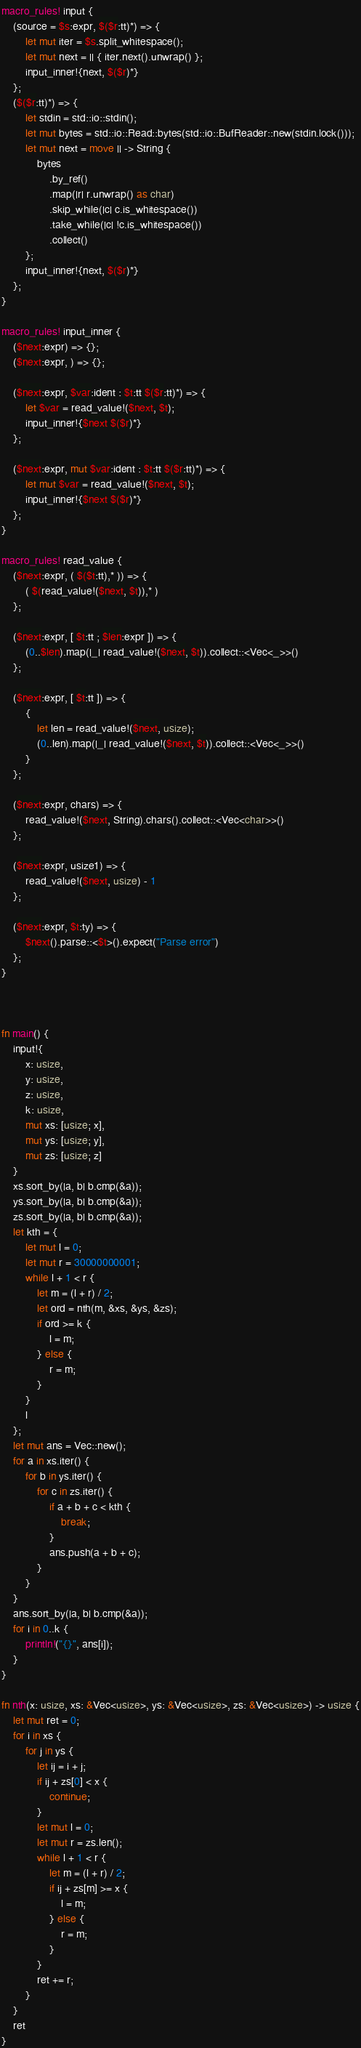<code> <loc_0><loc_0><loc_500><loc_500><_Rust_>macro_rules! input {
    (source = $s:expr, $($r:tt)*) => {
        let mut iter = $s.split_whitespace();
        let mut next = || { iter.next().unwrap() };
        input_inner!{next, $($r)*}
    };
    ($($r:tt)*) => {
        let stdin = std::io::stdin();
        let mut bytes = std::io::Read::bytes(std::io::BufReader::new(stdin.lock()));
        let mut next = move || -> String {
            bytes
                .by_ref()
                .map(|r| r.unwrap() as char)
                .skip_while(|c| c.is_whitespace())
                .take_while(|c| !c.is_whitespace())
                .collect()
        };
        input_inner!{next, $($r)*}
    };
}

macro_rules! input_inner {
    ($next:expr) => {};
    ($next:expr, ) => {};

    ($next:expr, $var:ident : $t:tt $($r:tt)*) => {
        let $var = read_value!($next, $t);
        input_inner!{$next $($r)*}
    };

    ($next:expr, mut $var:ident : $t:tt $($r:tt)*) => {
        let mut $var = read_value!($next, $t);
        input_inner!{$next $($r)*}
    };
}

macro_rules! read_value {
    ($next:expr, ( $($t:tt),* )) => {
        ( $(read_value!($next, $t)),* )
    };

    ($next:expr, [ $t:tt ; $len:expr ]) => {
        (0..$len).map(|_| read_value!($next, $t)).collect::<Vec<_>>()
    };

    ($next:expr, [ $t:tt ]) => {
        {
            let len = read_value!($next, usize);
            (0..len).map(|_| read_value!($next, $t)).collect::<Vec<_>>()
        }
    };

    ($next:expr, chars) => {
        read_value!($next, String).chars().collect::<Vec<char>>()
    };

    ($next:expr, usize1) => {
        read_value!($next, usize) - 1
    };

    ($next:expr, $t:ty) => {
        $next().parse::<$t>().expect("Parse error")
    };
}



fn main() {
    input!{
        x: usize,
        y: usize,
        z: usize,
        k: usize,
        mut xs: [usize; x],
        mut ys: [usize; y],
        mut zs: [usize; z]
    }
    xs.sort_by(|a, b| b.cmp(&a));
    ys.sort_by(|a, b| b.cmp(&a));
    zs.sort_by(|a, b| b.cmp(&a));
    let kth = {
        let mut l = 0;
        let mut r = 30000000001;
        while l + 1 < r {
            let m = (l + r) / 2;
            let ord = nth(m, &xs, &ys, &zs);
            if ord >= k {
                l = m;
            } else {
                r = m;
            }
        }
        l
    };
    let mut ans = Vec::new();
    for a in xs.iter() {
        for b in ys.iter() {
            for c in zs.iter() {
                if a + b + c < kth {
                    break;
                }
                ans.push(a + b + c);
            }
        }
    }
    ans.sort_by(|a, b| b.cmp(&a));
    for i in 0..k {
        println!("{}", ans[i]);
    }
}

fn nth(x: usize, xs: &Vec<usize>, ys: &Vec<usize>, zs: &Vec<usize>) -> usize {
    let mut ret = 0;
    for i in xs {
        for j in ys {
            let ij = i + j;
            if ij + zs[0] < x {
                continue;
            }
            let mut l = 0;
            let mut r = zs.len();
            while l + 1 < r {
                let m = (l + r) / 2;
                if ij + zs[m] >= x {
                    l = m;
                } else {
                    r = m;
                }
            }
            ret += r;
        }
    }
    ret
}
</code> 